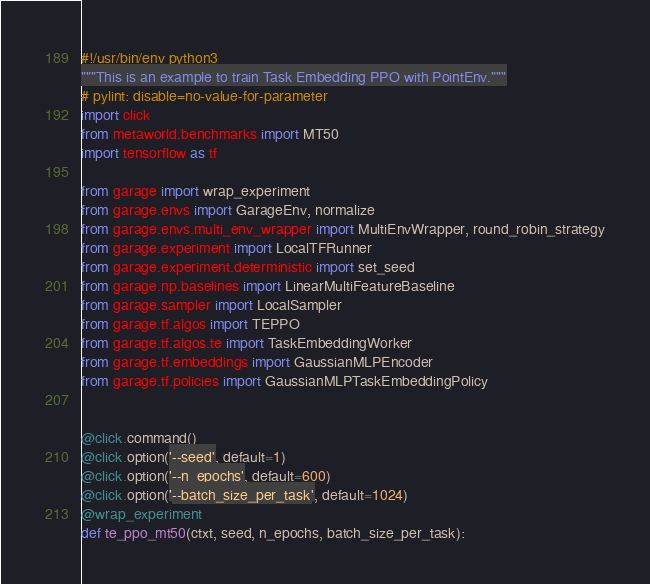Convert code to text. <code><loc_0><loc_0><loc_500><loc_500><_Python_>#!/usr/bin/env python3
"""This is an example to train Task Embedding PPO with PointEnv."""
# pylint: disable=no-value-for-parameter
import click
from metaworld.benchmarks import MT50
import tensorflow as tf

from garage import wrap_experiment
from garage.envs import GarageEnv, normalize
from garage.envs.multi_env_wrapper import MultiEnvWrapper, round_robin_strategy
from garage.experiment import LocalTFRunner
from garage.experiment.deterministic import set_seed
from garage.np.baselines import LinearMultiFeatureBaseline
from garage.sampler import LocalSampler
from garage.tf.algos import TEPPO
from garage.tf.algos.te import TaskEmbeddingWorker
from garage.tf.embeddings import GaussianMLPEncoder
from garage.tf.policies import GaussianMLPTaskEmbeddingPolicy


@click.command()
@click.option('--seed', default=1)
@click.option('--n_epochs', default=600)
@click.option('--batch_size_per_task', default=1024)
@wrap_experiment
def te_ppo_mt50(ctxt, seed, n_epochs, batch_size_per_task):</code> 